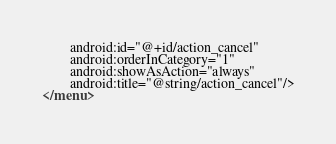Convert code to text. <code><loc_0><loc_0><loc_500><loc_500><_XML_>        android:id="@+id/action_cancel"
        android:orderInCategory="1"
        android:showAsAction="always"
        android:title="@string/action_cancel"/>
</menu></code> 